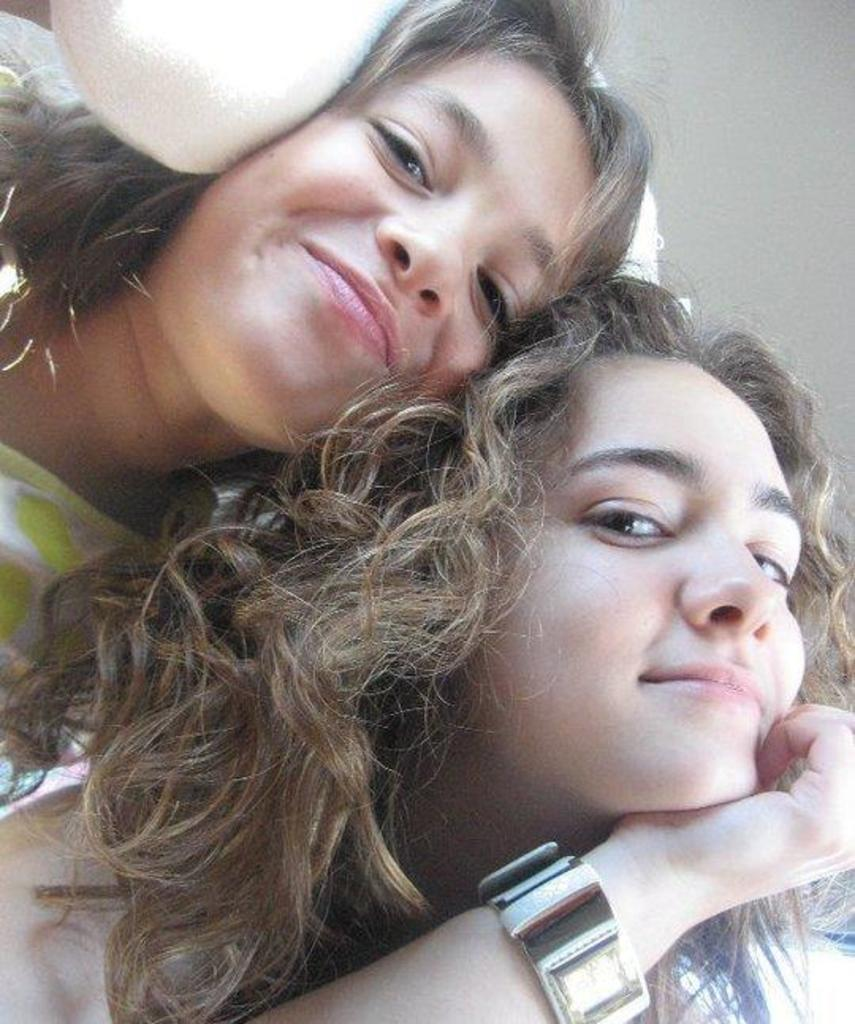How many people are wearing dresses in the image? There are two people with dresses in the image. Can you describe the person with a watch in the image? There is one person with a watch in the image. What is the color of the background in the image? The background of the image is white. Where are the toys located in the image? There are no toys present in the image. What type of girl is depicted in the image? There is no girl depicted in the image; the people in the image are wearing dresses, but their gender is not specified. 